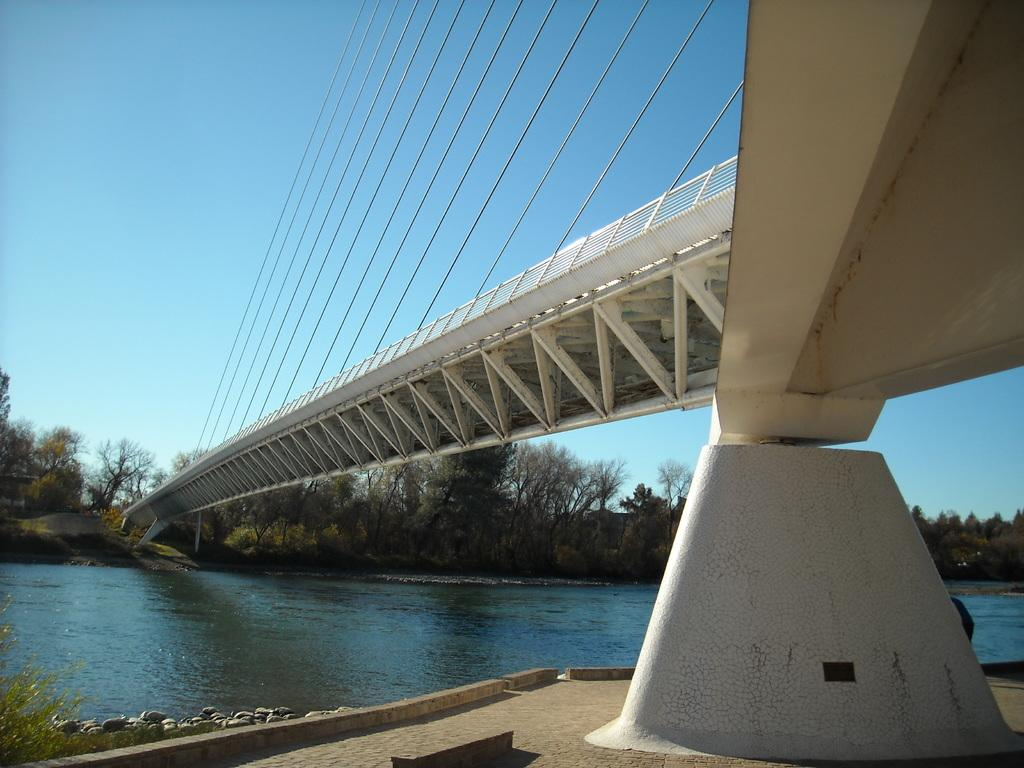What type of structure can be seen in the image? There is a bridge in the image. What natural element is visible near the bridge? There is water visible in the image. What type of vegetation is present in the image? There are trees in the image. What color is the sky in the image? The sky is blue in the image. Can you see any fog around the bridge in the image? There is no mention of fog in the image, so we cannot determine if it is present or not. 